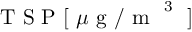Convert formula to latex. <formula><loc_0><loc_0><loc_500><loc_500>T S P [ \mu g / m ^ { 3 } ]</formula> 